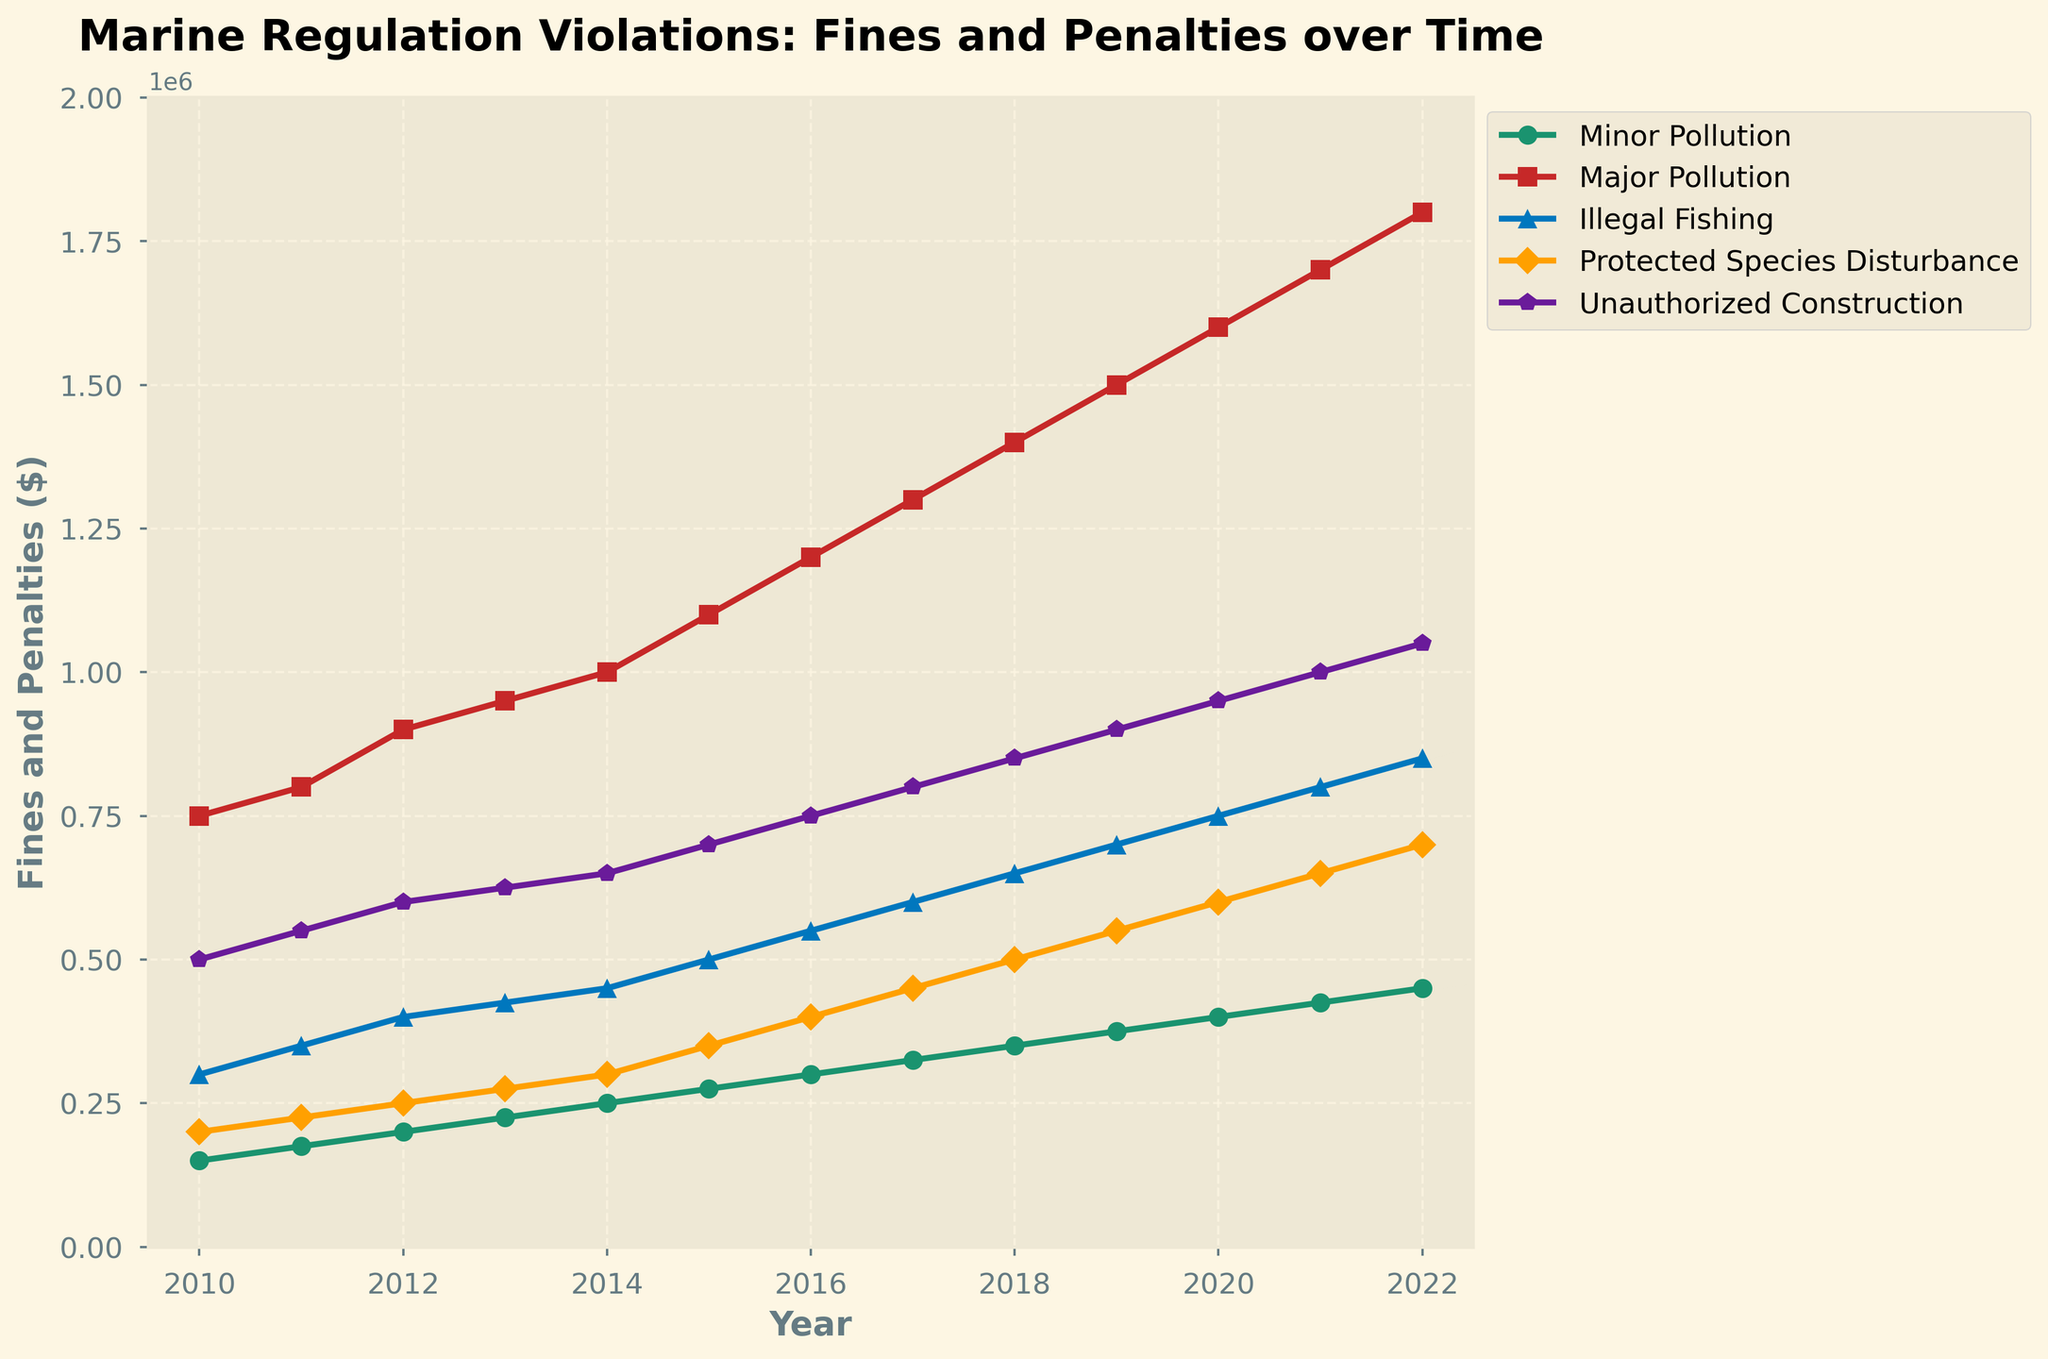What's the trend for fines due to Major Pollution over the years? The fines for Major Pollution show an increasing trend from 2010 to 2022, starting from $750,000 in 2010 and rising steadily to $1,800,000 by 2022.
Answer: Increasing trend Which infraction category had the highest fines in 2022? By referring to the endpoints of the plotted lines in the chart, Major Pollution had the highest fines in 2022 with $1,800,000.
Answer: Major Pollution In which year was the fine for Unauthorized Construction exactly $1,000,000? The line plot shows that the fine for Unauthorized Construction reached $1,000,000 in 2021.
Answer: 2021 What's the difference between the fines for Minor Pollution and Illegal Fishing in 2015? The fines for Minor Pollution and Illegal Fishing in 2015 were $275,000 and $500,000 respectively. The difference is calculated as $500,000 - $275,000 = $225,000.
Answer: $225,000 Which category experienced the steepest increase in fines between 2014 and 2015? By observing the slope of the lines between 2014 and 2015, Major Pollution experienced the steepest increase in fines, rising from $1,000,000 to $1,100,000, a difference of $100,000.
Answer: Major Pollution How much did the fines for Protected Species Disturbance increase from 2010 to 2022? The fines for Protected Species Disturbance increased from $200,000 in 2010 to $700,000 in 2022. The increment is $700,000 - $200,000 = $500,000.
Answer: $500,000 What's the average fine for Illegal Fishing over the entire period? Adding the fines for Illegal Fishing from 2010 to 2022 gives a total of $6,025,000. Dividing this by the 13 years of data, the average fine is $602,500.
Answer: $602,500 Did any category see a period of decline in fines over the time span provided? By tracing the lines from 2010 to 2022, no category experienced a period of decline; all categories exhibit an upward trend throughout the period.
Answer: No Which year saw the highest cumulative fines across all categories? Summing up the fines across all categories for each year, 2022 has the highest cumulative fines: $450,000 (Minor Pollution) + $1,800,000 (Major Pollution) + $850,000 (Illegal Fishing) + $700,000 (Protected Species Disturbance) + $1,050,000 (Unauthorized Construction) = $4,850,000.
Answer: 2022 